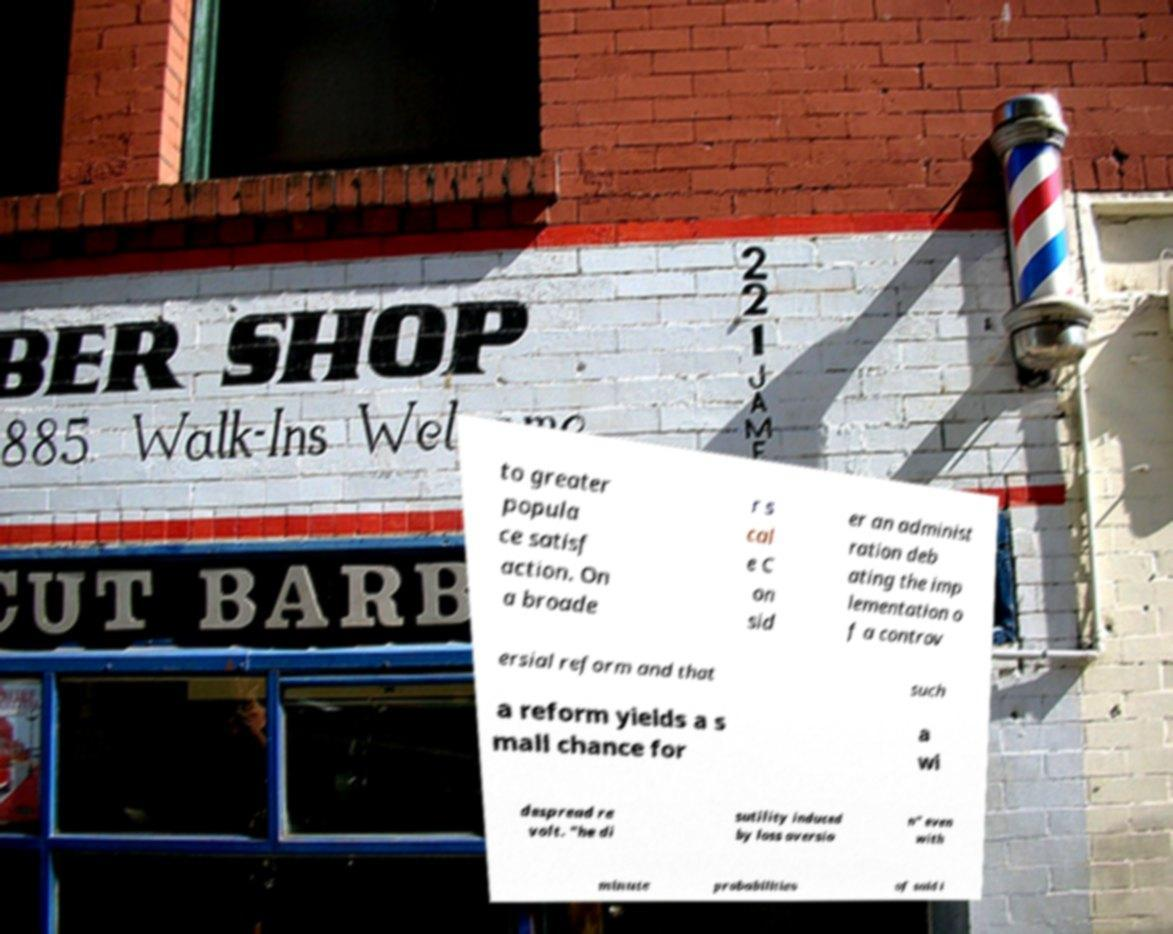What messages or text are displayed in this image? I need them in a readable, typed format. to greater popula ce satisf action. On a broade r s cal e C on sid er an administ ration deb ating the imp lementation o f a controv ersial reform and that such a reform yields a s mall chance for a wi despread re volt. "he di sutility induced by loss aversio n" even with minute probabilities of said i 